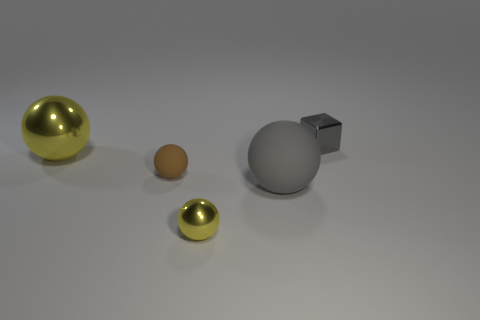Does the big matte object have the same color as the metal block?
Offer a very short reply. Yes. What is the size of the thing that is both left of the small gray thing and on the right side of the small yellow shiny sphere?
Give a very brief answer. Large. What is the color of the large shiny ball?
Make the answer very short. Yellow. How many yellow objects are there?
Provide a short and direct response. 2. How many tiny metallic things are the same color as the big rubber thing?
Your response must be concise. 1. Does the tiny shiny thing on the left side of the small metallic block have the same shape as the tiny metal object that is on the right side of the tiny yellow metal object?
Offer a very short reply. No. There is a large ball that is on the right side of the small shiny object that is in front of the small brown rubber thing on the left side of the small yellow metal ball; what color is it?
Your answer should be very brief. Gray. There is a tiny metallic object to the left of the block; what is its color?
Provide a short and direct response. Yellow. What is the color of the other metallic sphere that is the same size as the gray ball?
Offer a very short reply. Yellow. Is the metal cube the same size as the gray matte sphere?
Keep it short and to the point. No. 